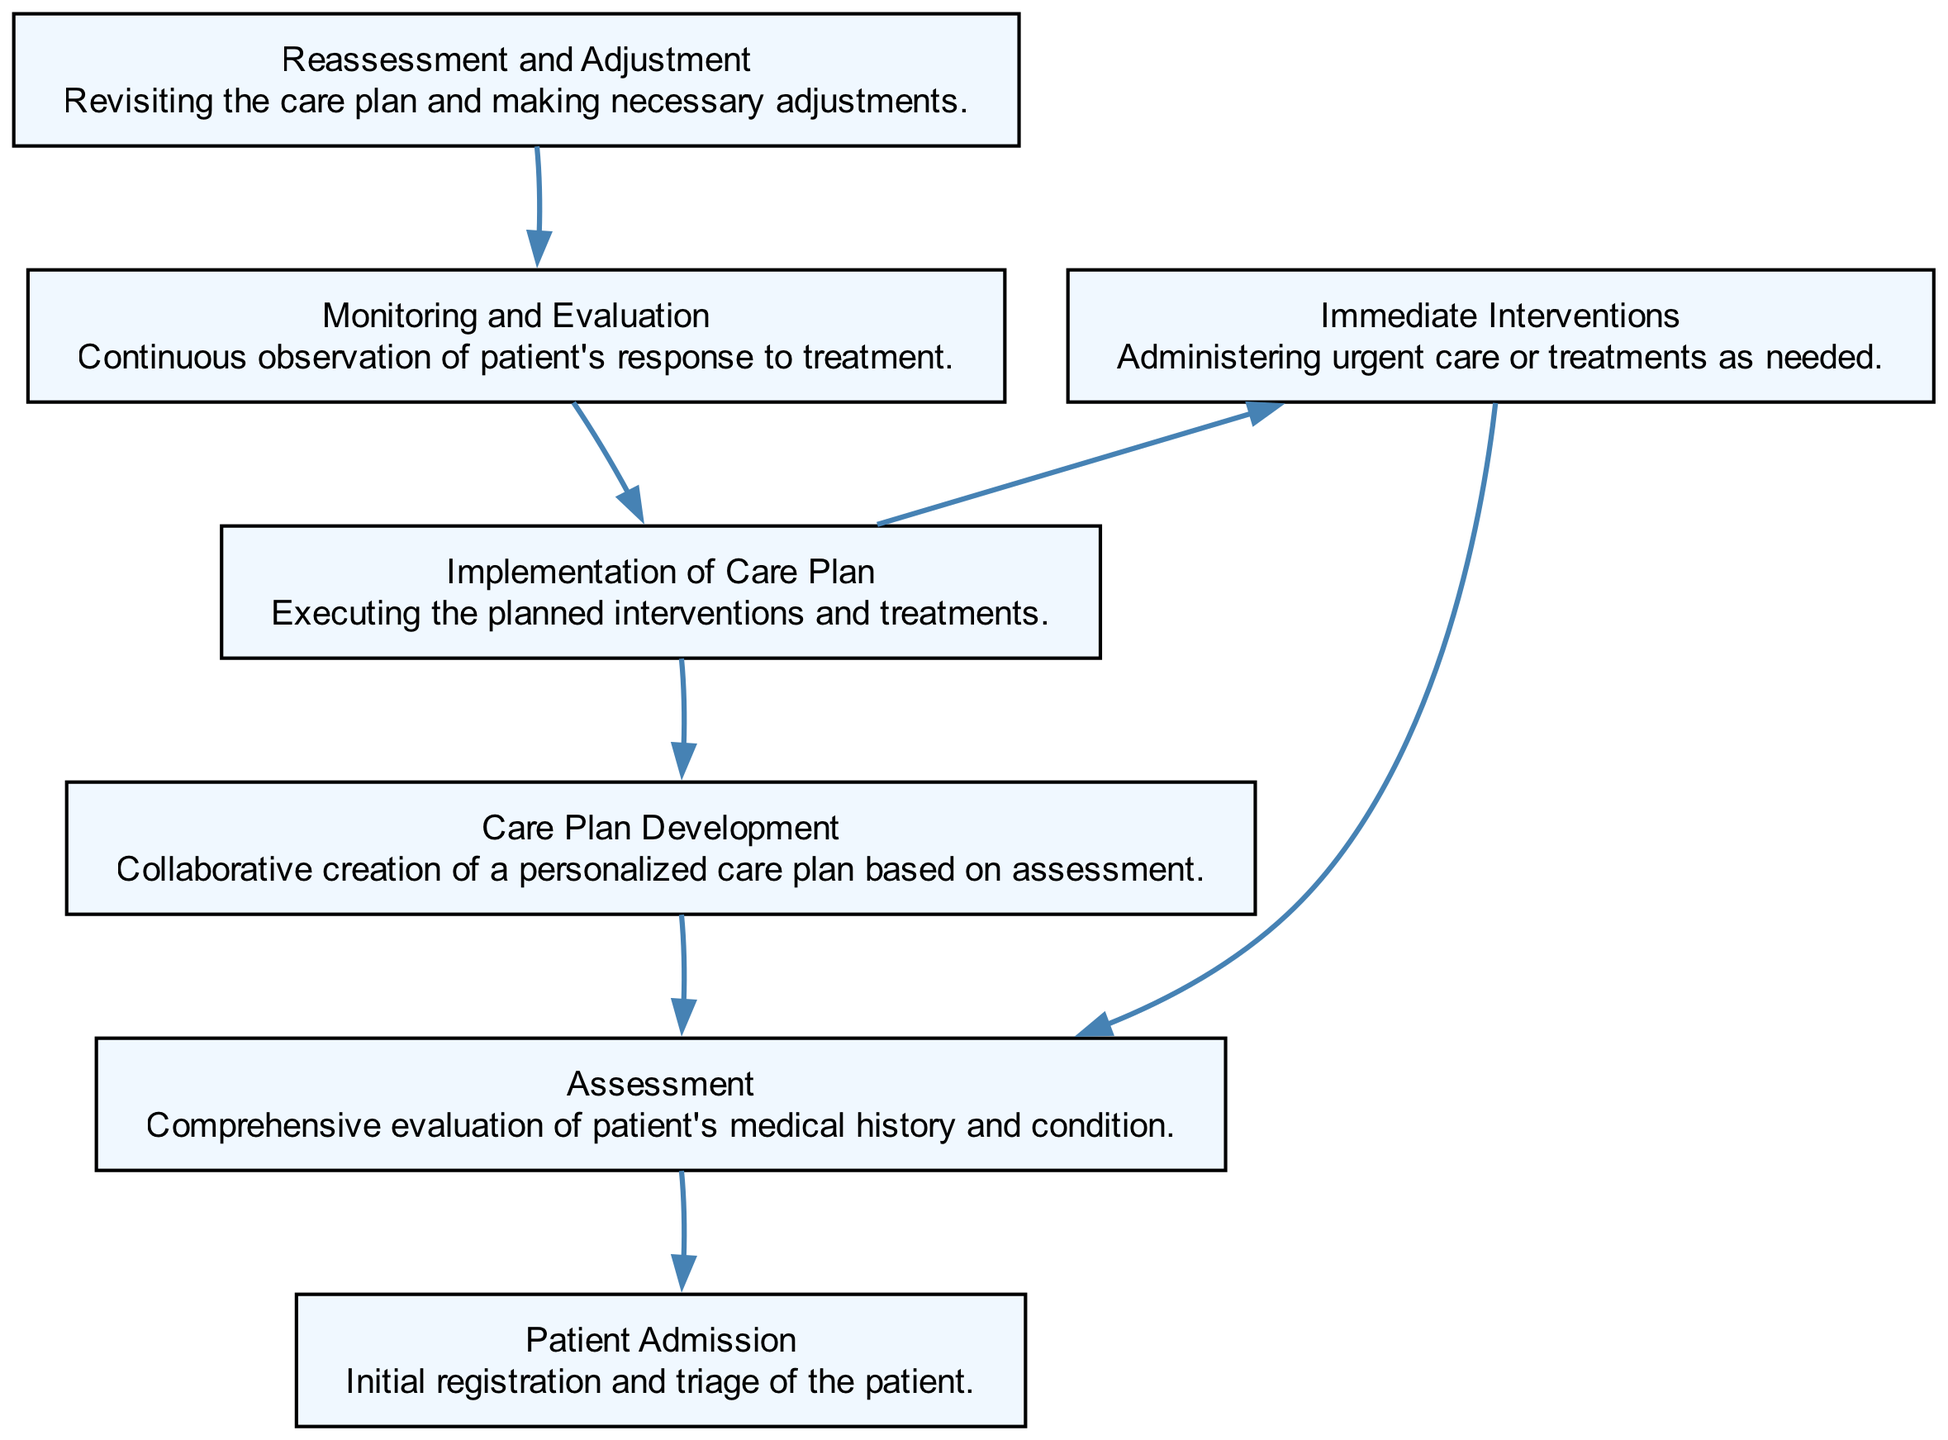What is the first step in the patient care process? The diagram indicates that the first step is "Patient Admission." This is shown as the initial node in the flow chart.
Answer: Patient Admission How many steps are there from assessment to care plan development? The flow chart shows that there is one step between "Assessment" and "Care Plan Development," which means that "Care Plan Development" directly follows "Assessment."
Answer: 1 What is administered in the "Immediate Interventions" step? The description of "Immediate Interventions" indicates that urgent care or treatments are provided in this step. It doesn’t specify the exact treatments but implies urgent actions.
Answer: Urgent care or treatments What are the two next potential steps after assessment? The diagram lists "Care Plan Development" and "Immediate Interventions" as the two next steps that flow from the "Assessment" node.
Answer: Care Plan Development and Immediate Interventions Which step follows the "Implementation of Care Plan"? According to the flow chart, the step that follows "Implementation of Care Plan" is "Monitoring and Evaluation." This signifies ongoing assessment after carrying out the care plan.
Answer: Monitoring and Evaluation At which step does the continuous observation of the patient's response to treatment occur? The step for continuous observation of the patient's response to treatment is specified as "Monitoring and Evaluation" in the flow chart. This suggests that monitoring is a key activity in this phase.
Answer: Monitoring and Evaluation What does the "Reassessment and Adjustment" step focus on? The description of "Reassessment and Adjustment" indicates that it focuses on revisiting the care plan and making necessary adjustments, reinforcing its role in ensuring effective care.
Answer: Revisiting the care plan and making adjustments What is the end point of the patient care process flow? The flow chart indicates that the last point in the patient care process is "Reassessment and Adjustment," as there are no further steps that follow it.
Answer: Reassessment and Adjustment 